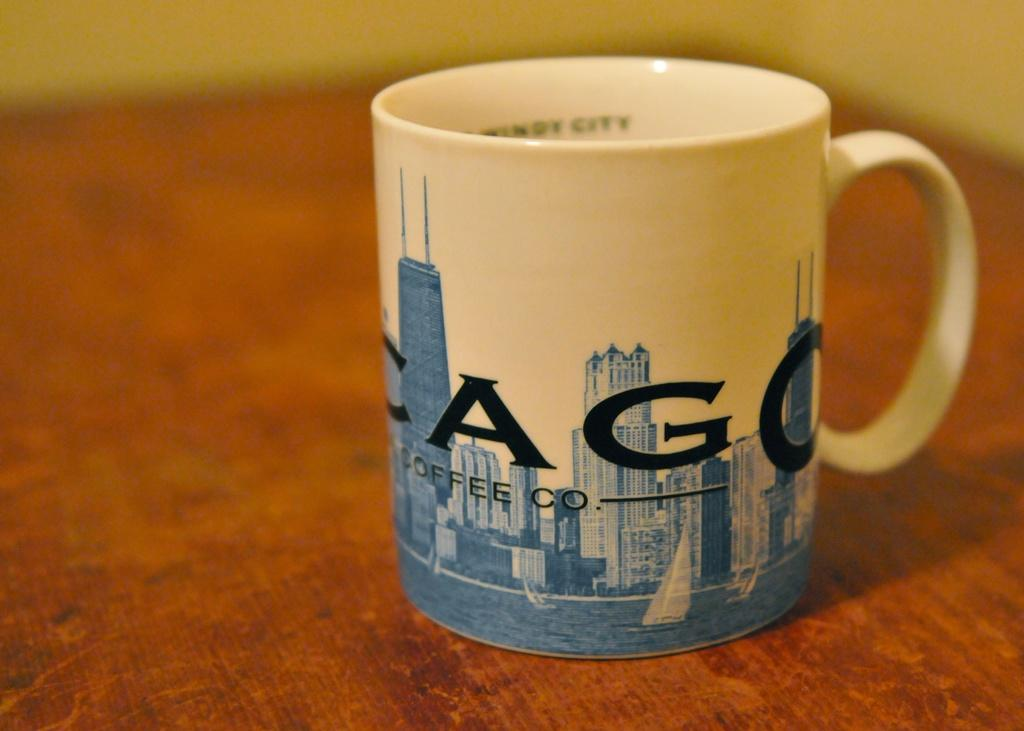<image>
Share a concise interpretation of the image provided. A coffe cup with the word coffee co. on it 